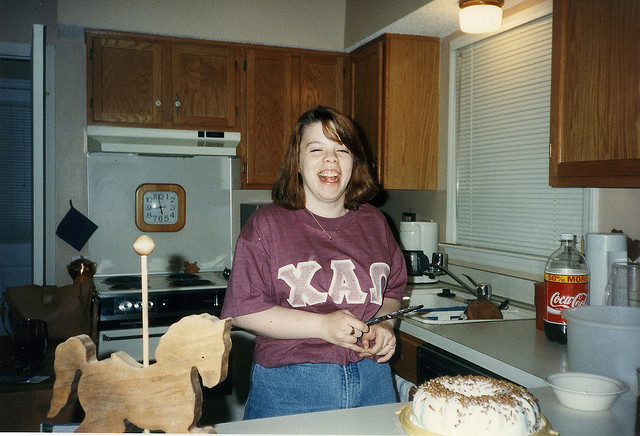Identify and read out the text in this image. XAS Coca MOK 3 2 1 12 11 4 5 6 7 8 9 10 